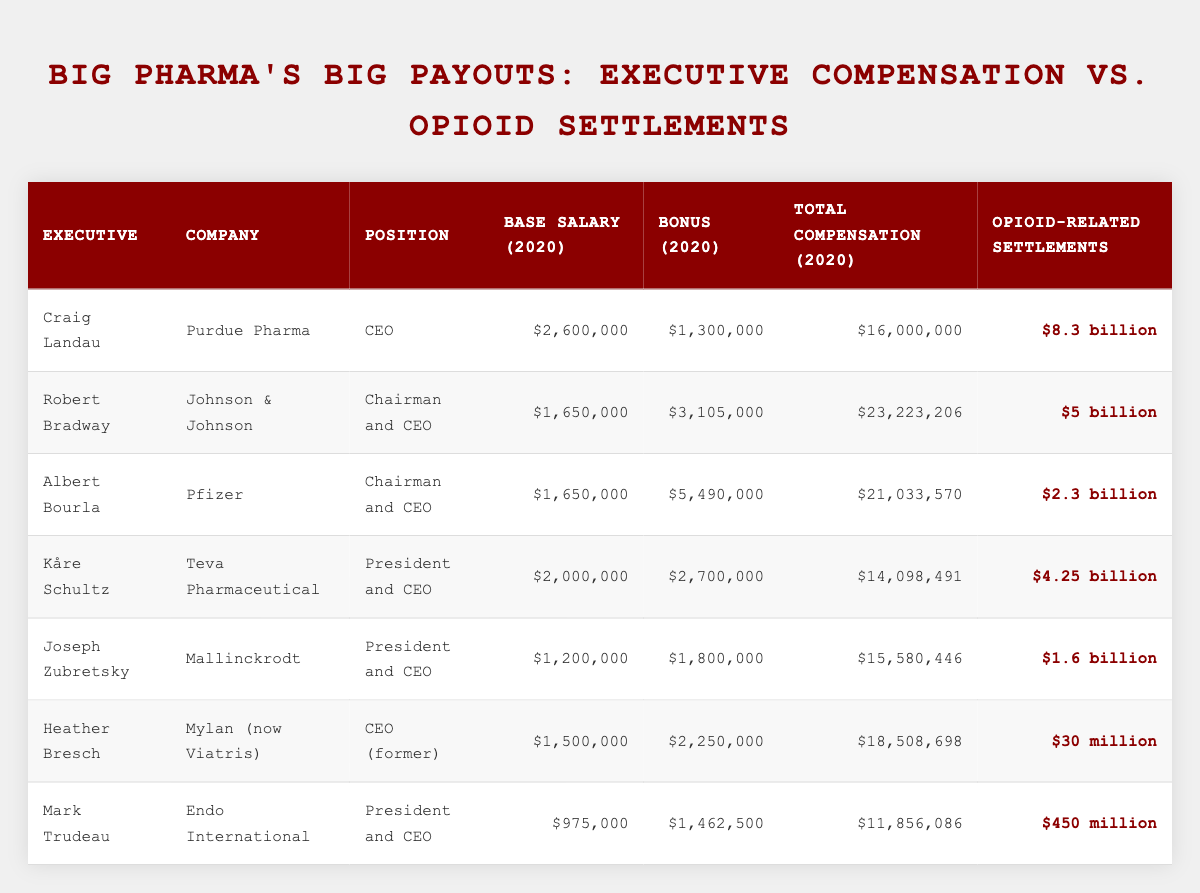What is the total compensation for Craig Landau in 2020? According to the table, Craig Landau's total compensation is listed as $16,000,000.
Answer: $16,000,000 Which company had the highest base salary for its CEO in 2020? The table indicates that Purdue Pharma, with Craig Landau as CEO, received the highest base salary at $2,600,000.
Answer: Purdue Pharma How much did Robert Bradway earn in bonuses in 2020? The table shows that Robert Bradway's bonus is $3,105,000 for 2020.
Answer: $3,105,000 What is the total opioid-related settlements for the executive with the lowest total compensation? Looking at the table, Mark Trudeau from Endo International has the lowest total compensation at $11,856,086, and his company's opioid-related settlements are $450 million.
Answer: $450 million Is it true that all executives listed received total compensations over $10 million in 2020? Checking the table, all executives have total compensations exceeding $10 million, with the lowest being $11,856,086 for Mark Trudeau.
Answer: Yes What is the average total compensation of the executives in the table? To find the average, add the total compensation amounts: $16,000,000 + $23,223,206 + $21,033,570 + $14,098,491 + $15,580,446 + $18,508,698 + $11,856,086 = $119,300,497. Then divide by 7 (the number of executives), resulting in an average of approximately $17,757,213.
Answer: $17,757,213 Which executive received the lowest bonus in 2020, and what was the amount? The table reveals that Mark Trudeau received the lowest bonus, amounting to $1,462,500, making him the executive with the least bonus in the year 2020.
Answer: $1,462,500 How much higher is Craig Landau's total compensation compared to Joseph Zubretsky's? Craig Landau's total compensation is $16,000,000, while Joseph Zubretsky's is $15,580,446. The difference is calculated as $16,000,000 - $15,580,446 = $419,554, indicating Craig Landau earns $419,554 more.
Answer: $419,554 What percentage of opioid-related settlements does the total compensation for Kåre Schultz represent? Kåre Schultz received a total compensation of $14,098,491, and the opioid-related settlements for his company are $4.25 billion. To find the percentage: ($14,098,491 / 4,250,000,000) * 100 = 0.331%. This represents approximately 0.331% of the settlements.
Answer: 0.331% 